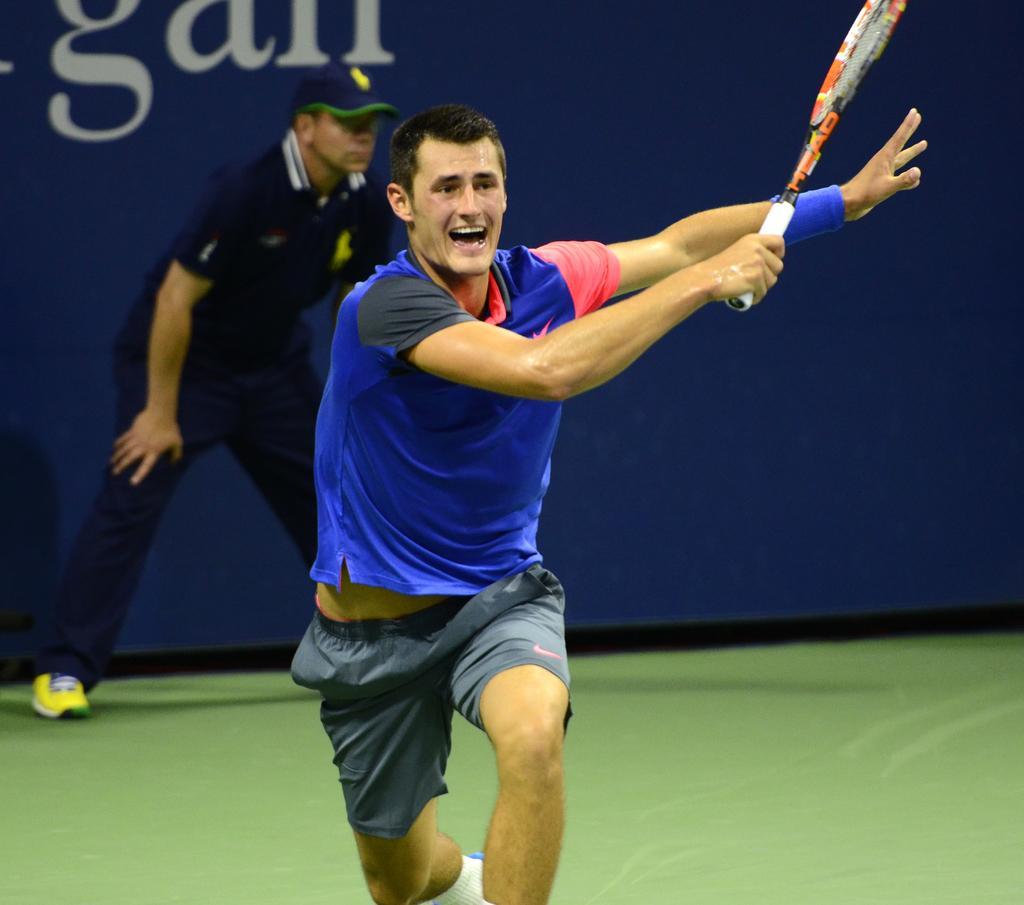In one or two sentences, can you explain what this image depicts? In this picture a blue shirt guy is playing a tennis and in the background there is a blue wall and a ball boy. 